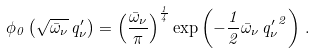<formula> <loc_0><loc_0><loc_500><loc_500>\phi _ { 0 } \left ( \sqrt { \bar { \omega } _ { \nu } } \, q ^ { \prime } _ { \nu } \right ) = \left ( \frac { \bar { \omega } _ { \nu } } { \pi } \right ) ^ { \frac { 1 } { 4 } } \exp \left ( - \frac { 1 } { 2 } \bar { \omega } _ { \nu } \, { q ^ { \prime } _ { \nu } } ^ { 2 } \right ) \, .</formula> 